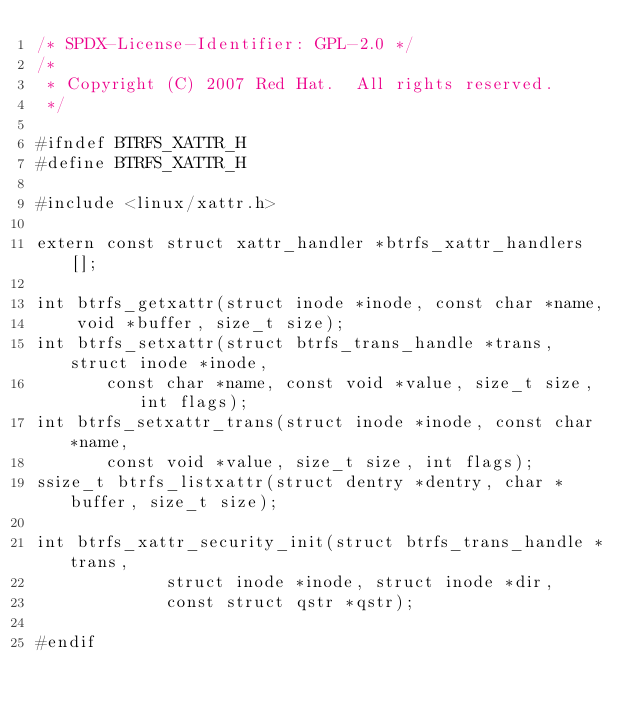Convert code to text. <code><loc_0><loc_0><loc_500><loc_500><_C_>/* SPDX-License-Identifier: GPL-2.0 */
/*
 * Copyright (C) 2007 Red Hat.  All rights reserved.
 */

#ifndef BTRFS_XATTR_H
#define BTRFS_XATTR_H

#include <linux/xattr.h>

extern const struct xattr_handler *btrfs_xattr_handlers[];

int btrfs_getxattr(struct inode *inode, const char *name,
		void *buffer, size_t size);
int btrfs_setxattr(struct btrfs_trans_handle *trans, struct inode *inode,
		   const char *name, const void *value, size_t size, int flags);
int btrfs_setxattr_trans(struct inode *inode, const char *name,
			 const void *value, size_t size, int flags);
ssize_t btrfs_listxattr(struct dentry *dentry, char *buffer, size_t size);

int btrfs_xattr_security_init(struct btrfs_trans_handle *trans,
				     struct inode *inode, struct inode *dir,
				     const struct qstr *qstr);

#endif
</code> 